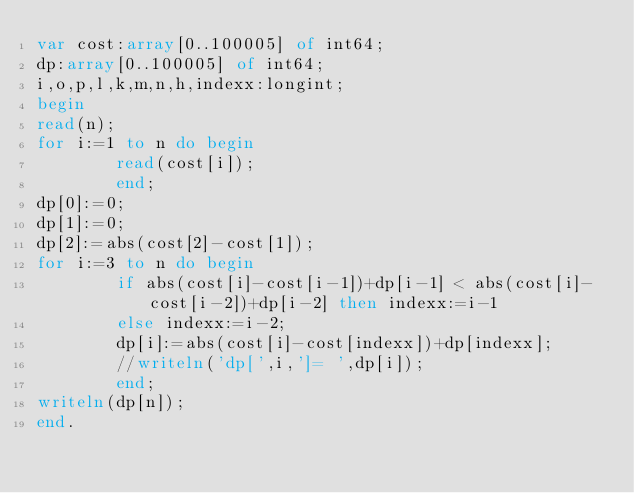<code> <loc_0><loc_0><loc_500><loc_500><_Pascal_>var cost:array[0..100005] of int64;
dp:array[0..100005] of int64;
i,o,p,l,k,m,n,h,indexx:longint;
begin
read(n);
for i:=1 to n do begin
        read(cost[i]);
        end;
dp[0]:=0;
dp[1]:=0;
dp[2]:=abs(cost[2]-cost[1]);
for i:=3 to n do begin
        if abs(cost[i]-cost[i-1])+dp[i-1] < abs(cost[i]-cost[i-2])+dp[i-2] then indexx:=i-1
        else indexx:=i-2;
        dp[i]:=abs(cost[i]-cost[indexx])+dp[indexx];
        //writeln('dp[',i,']= ',dp[i]);
        end;
writeln(dp[n]);
end.

</code> 